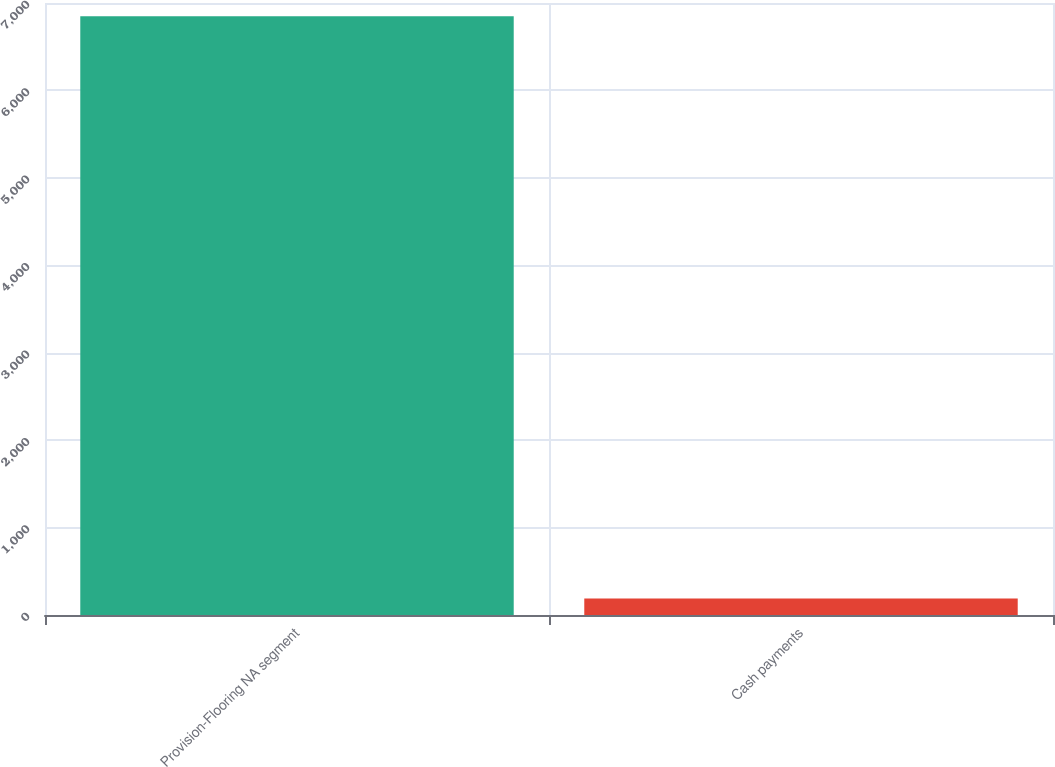<chart> <loc_0><loc_0><loc_500><loc_500><bar_chart><fcel>Provision-Flooring NA segment<fcel>Cash payments<nl><fcel>6849<fcel>190<nl></chart> 